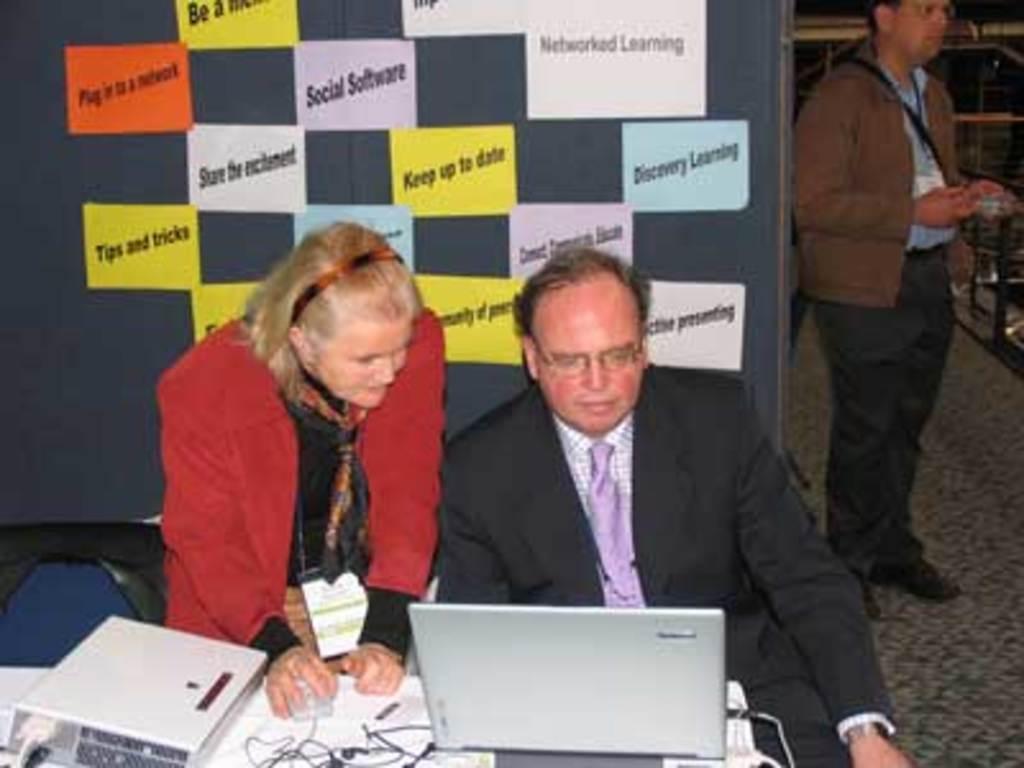Can you describe this image briefly? In this picture the person wearing suit is sitting and operating a laptop in front of him and there is another woman standing beside him placed her hand on a mouse in front of her and there are some other objects in the background. 